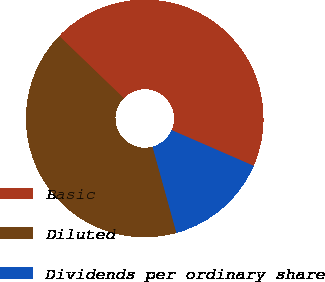Convert chart to OTSL. <chart><loc_0><loc_0><loc_500><loc_500><pie_chart><fcel>Basic<fcel>Diluted<fcel>Dividends per ordinary share<nl><fcel>44.34%<fcel>41.51%<fcel>14.16%<nl></chart> 